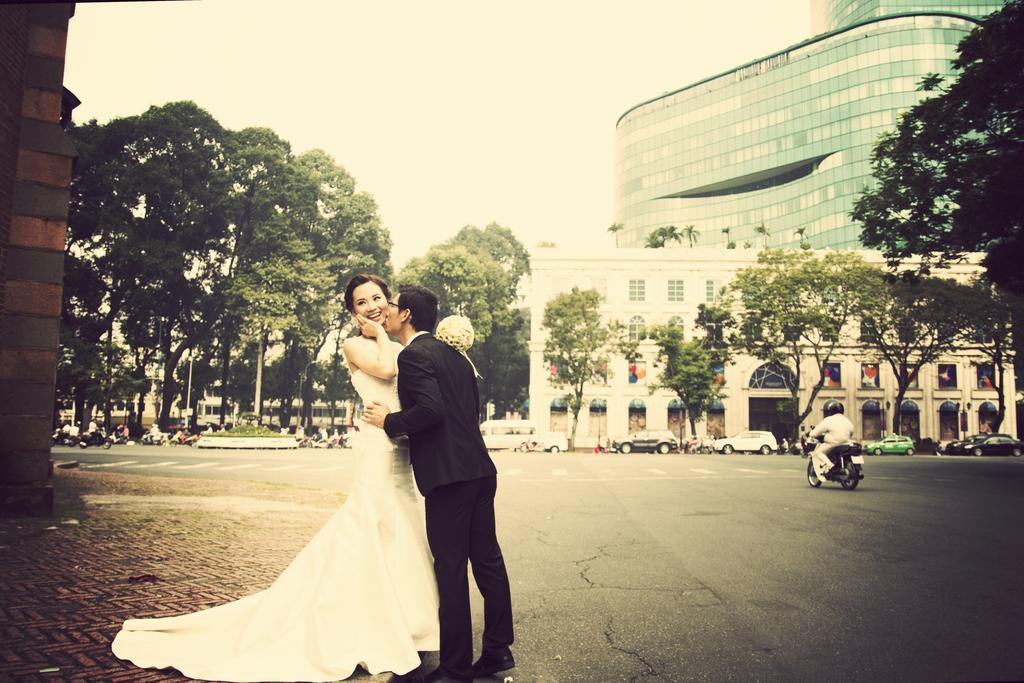Could you give a brief overview of what you see in this image? In this picture, we can see a few people, among them a bride and bridegroom are highlighted, we can see the ground, road, trees, buildings, vehicles and the sky. 